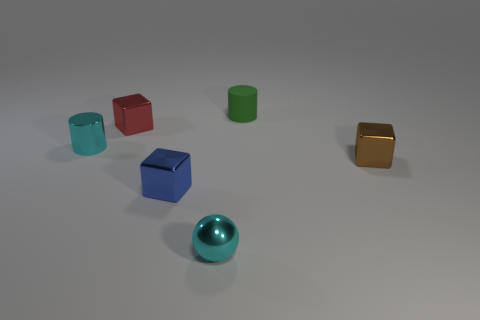Subtract all small red shiny cubes. How many cubes are left? 2 Add 4 tiny brown metallic blocks. How many objects exist? 10 Subtract all tiny red matte cylinders. Subtract all metallic cylinders. How many objects are left? 5 Add 1 cyan metallic cylinders. How many cyan metallic cylinders are left? 2 Add 1 large gray metallic things. How many large gray metallic things exist? 1 Subtract all green cylinders. How many cylinders are left? 1 Subtract 1 red cubes. How many objects are left? 5 Subtract all spheres. How many objects are left? 5 Subtract 1 blocks. How many blocks are left? 2 Subtract all yellow cylinders. Subtract all blue spheres. How many cylinders are left? 2 